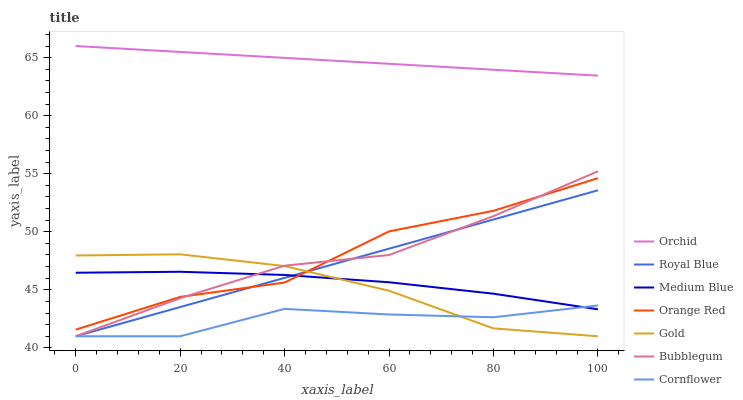Does Gold have the minimum area under the curve?
Answer yes or no. No. Does Gold have the maximum area under the curve?
Answer yes or no. No. Is Gold the smoothest?
Answer yes or no. No. Is Gold the roughest?
Answer yes or no. No. Does Medium Blue have the lowest value?
Answer yes or no. No. Does Gold have the highest value?
Answer yes or no. No. Is Orange Red less than Orchid?
Answer yes or no. Yes. Is Orchid greater than Medium Blue?
Answer yes or no. Yes. Does Orange Red intersect Orchid?
Answer yes or no. No. 